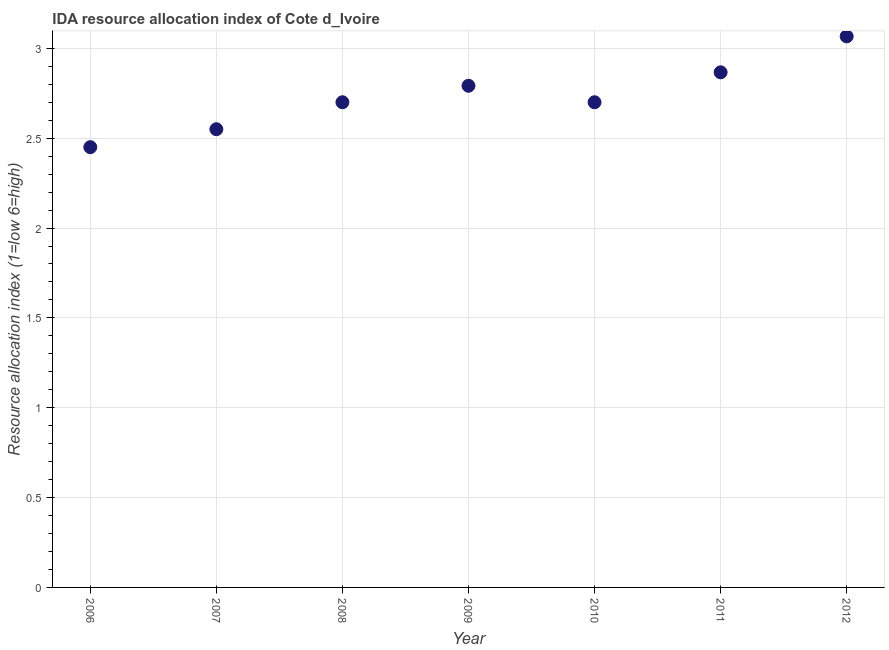What is the ida resource allocation index in 2007?
Ensure brevity in your answer.  2.55. Across all years, what is the maximum ida resource allocation index?
Offer a very short reply. 3.07. Across all years, what is the minimum ida resource allocation index?
Ensure brevity in your answer.  2.45. In which year was the ida resource allocation index maximum?
Ensure brevity in your answer.  2012. In which year was the ida resource allocation index minimum?
Your answer should be compact. 2006. What is the sum of the ida resource allocation index?
Give a very brief answer. 19.13. What is the difference between the ida resource allocation index in 2007 and 2008?
Give a very brief answer. -0.15. What is the average ida resource allocation index per year?
Ensure brevity in your answer.  2.73. In how many years, is the ida resource allocation index greater than 2.1 ?
Make the answer very short. 7. What is the ratio of the ida resource allocation index in 2006 to that in 2010?
Keep it short and to the point. 0.91. What is the difference between the highest and the second highest ida resource allocation index?
Make the answer very short. 0.2. Is the sum of the ida resource allocation index in 2006 and 2010 greater than the maximum ida resource allocation index across all years?
Make the answer very short. Yes. What is the difference between the highest and the lowest ida resource allocation index?
Your answer should be very brief. 0.62. In how many years, is the ida resource allocation index greater than the average ida resource allocation index taken over all years?
Provide a short and direct response. 3. Does the ida resource allocation index monotonically increase over the years?
Your response must be concise. No. How many years are there in the graph?
Keep it short and to the point. 7. What is the difference between two consecutive major ticks on the Y-axis?
Give a very brief answer. 0.5. Does the graph contain grids?
Keep it short and to the point. Yes. What is the title of the graph?
Keep it short and to the point. IDA resource allocation index of Cote d_Ivoire. What is the label or title of the X-axis?
Provide a succinct answer. Year. What is the label or title of the Y-axis?
Your answer should be very brief. Resource allocation index (1=low 6=high). What is the Resource allocation index (1=low 6=high) in 2006?
Your answer should be very brief. 2.45. What is the Resource allocation index (1=low 6=high) in 2007?
Ensure brevity in your answer.  2.55. What is the Resource allocation index (1=low 6=high) in 2008?
Your response must be concise. 2.7. What is the Resource allocation index (1=low 6=high) in 2009?
Your answer should be very brief. 2.79. What is the Resource allocation index (1=low 6=high) in 2010?
Offer a very short reply. 2.7. What is the Resource allocation index (1=low 6=high) in 2011?
Your answer should be compact. 2.87. What is the Resource allocation index (1=low 6=high) in 2012?
Give a very brief answer. 3.07. What is the difference between the Resource allocation index (1=low 6=high) in 2006 and 2007?
Ensure brevity in your answer.  -0.1. What is the difference between the Resource allocation index (1=low 6=high) in 2006 and 2008?
Offer a terse response. -0.25. What is the difference between the Resource allocation index (1=low 6=high) in 2006 and 2009?
Offer a terse response. -0.34. What is the difference between the Resource allocation index (1=low 6=high) in 2006 and 2011?
Your answer should be compact. -0.42. What is the difference between the Resource allocation index (1=low 6=high) in 2006 and 2012?
Keep it short and to the point. -0.62. What is the difference between the Resource allocation index (1=low 6=high) in 2007 and 2009?
Provide a succinct answer. -0.24. What is the difference between the Resource allocation index (1=low 6=high) in 2007 and 2011?
Give a very brief answer. -0.32. What is the difference between the Resource allocation index (1=low 6=high) in 2007 and 2012?
Your answer should be very brief. -0.52. What is the difference between the Resource allocation index (1=low 6=high) in 2008 and 2009?
Provide a short and direct response. -0.09. What is the difference between the Resource allocation index (1=low 6=high) in 2008 and 2010?
Offer a very short reply. 0. What is the difference between the Resource allocation index (1=low 6=high) in 2008 and 2011?
Make the answer very short. -0.17. What is the difference between the Resource allocation index (1=low 6=high) in 2008 and 2012?
Give a very brief answer. -0.37. What is the difference between the Resource allocation index (1=low 6=high) in 2009 and 2010?
Offer a terse response. 0.09. What is the difference between the Resource allocation index (1=low 6=high) in 2009 and 2011?
Your answer should be very brief. -0.07. What is the difference between the Resource allocation index (1=low 6=high) in 2009 and 2012?
Offer a very short reply. -0.28. What is the difference between the Resource allocation index (1=low 6=high) in 2010 and 2011?
Provide a succinct answer. -0.17. What is the difference between the Resource allocation index (1=low 6=high) in 2010 and 2012?
Provide a short and direct response. -0.37. What is the difference between the Resource allocation index (1=low 6=high) in 2011 and 2012?
Make the answer very short. -0.2. What is the ratio of the Resource allocation index (1=low 6=high) in 2006 to that in 2007?
Keep it short and to the point. 0.96. What is the ratio of the Resource allocation index (1=low 6=high) in 2006 to that in 2008?
Provide a short and direct response. 0.91. What is the ratio of the Resource allocation index (1=low 6=high) in 2006 to that in 2009?
Ensure brevity in your answer.  0.88. What is the ratio of the Resource allocation index (1=low 6=high) in 2006 to that in 2010?
Your answer should be compact. 0.91. What is the ratio of the Resource allocation index (1=low 6=high) in 2006 to that in 2011?
Offer a very short reply. 0.85. What is the ratio of the Resource allocation index (1=low 6=high) in 2006 to that in 2012?
Make the answer very short. 0.8. What is the ratio of the Resource allocation index (1=low 6=high) in 2007 to that in 2008?
Provide a short and direct response. 0.94. What is the ratio of the Resource allocation index (1=low 6=high) in 2007 to that in 2009?
Give a very brief answer. 0.91. What is the ratio of the Resource allocation index (1=low 6=high) in 2007 to that in 2010?
Provide a short and direct response. 0.94. What is the ratio of the Resource allocation index (1=low 6=high) in 2007 to that in 2011?
Offer a terse response. 0.89. What is the ratio of the Resource allocation index (1=low 6=high) in 2007 to that in 2012?
Your response must be concise. 0.83. What is the ratio of the Resource allocation index (1=low 6=high) in 2008 to that in 2009?
Make the answer very short. 0.97. What is the ratio of the Resource allocation index (1=low 6=high) in 2008 to that in 2011?
Your answer should be very brief. 0.94. What is the ratio of the Resource allocation index (1=low 6=high) in 2009 to that in 2010?
Your answer should be compact. 1.03. What is the ratio of the Resource allocation index (1=low 6=high) in 2009 to that in 2012?
Your response must be concise. 0.91. What is the ratio of the Resource allocation index (1=low 6=high) in 2010 to that in 2011?
Your answer should be compact. 0.94. What is the ratio of the Resource allocation index (1=low 6=high) in 2010 to that in 2012?
Provide a short and direct response. 0.88. What is the ratio of the Resource allocation index (1=low 6=high) in 2011 to that in 2012?
Your answer should be very brief. 0.94. 